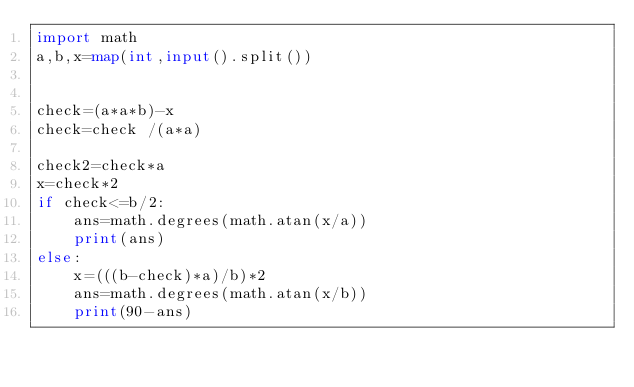Convert code to text. <code><loc_0><loc_0><loc_500><loc_500><_Python_>import math
a,b,x=map(int,input().split())


check=(a*a*b)-x
check=check /(a*a)

check2=check*a
x=check*2
if check<=b/2:
    ans=math.degrees(math.atan(x/a))
    print(ans)
else:
    x=(((b-check)*a)/b)*2
    ans=math.degrees(math.atan(x/b))
    print(90-ans)</code> 